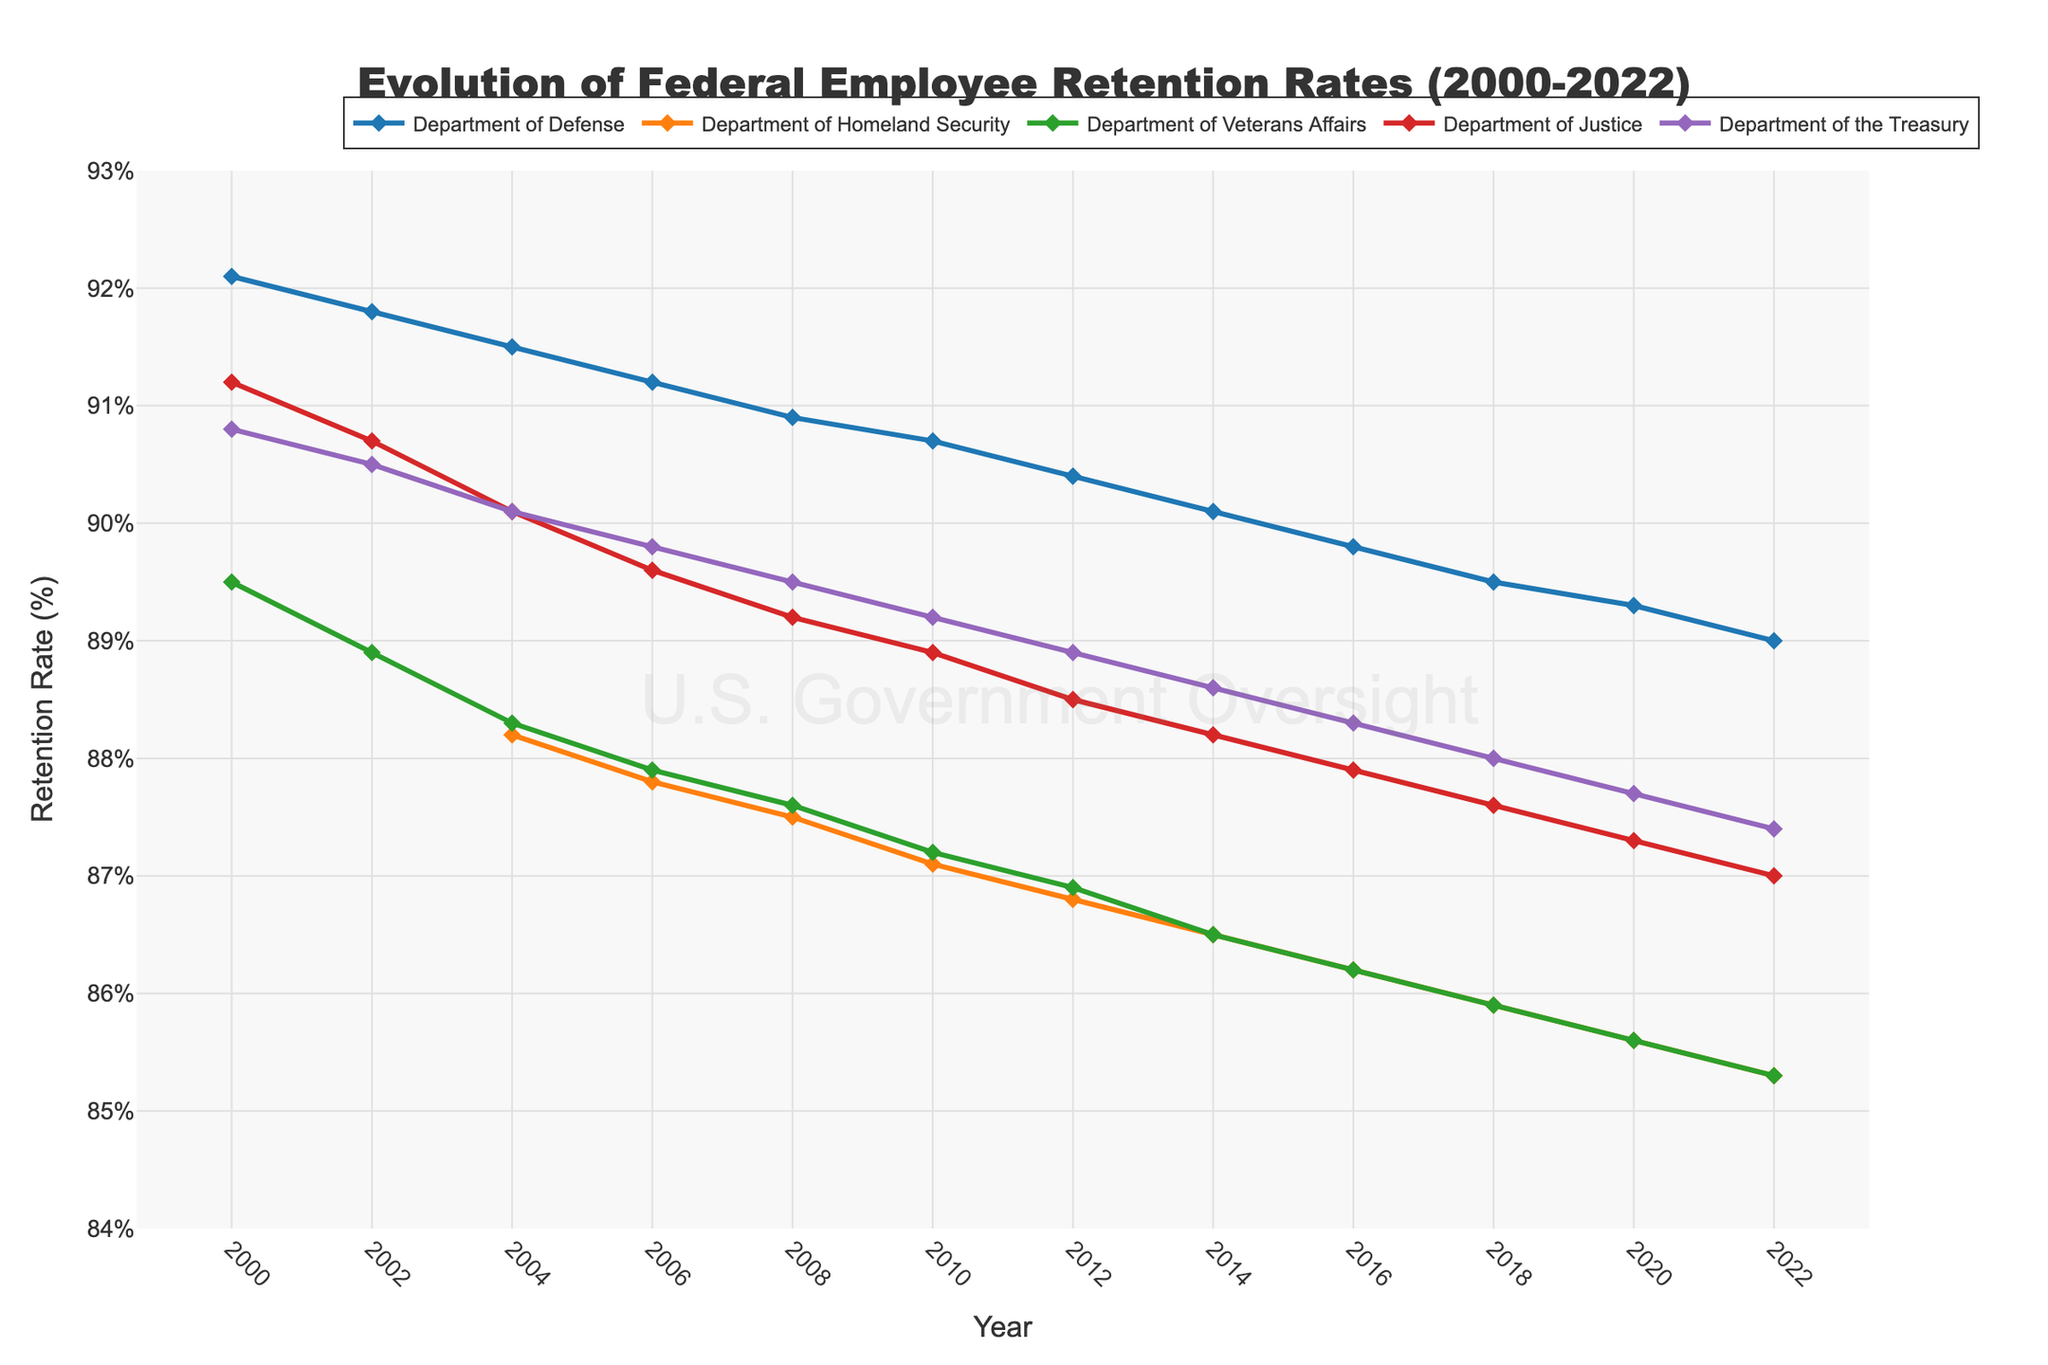Which agency had the highest retention rate in 2022? Look at the retention rates for each agency in 2022. The Department of Defense has the highest rate at 89.0%.
Answer: Department of Defense Comparing the Department of Homeland Security and the Department of Veterans Affairs, which had a higher retention rate in 2010? In 2010, the Department of Homeland Security had a retention rate of 87.1%, and the Department of Veterans Affairs had a retention rate of 87.2%. Thus, the Department of Veterans Affairs had a slightly higher retention rate.
Answer: Department of Veterans Affairs What is the average retention rate of the Department of the Treasury over the years 2000, 2002, and 2004? The retention rates for the Department of the Treasury in 2000, 2002, and 2004 are 90.8%, 90.5%, and 90.1%, respectively. The average is (90.8 + 90.5 + 90.1) / 3 = 90.47%.
Answer: 90.47% By how much did the retention rate of the Department of Justice change from 2000 to 2022? The retention rate of the Department of Justice in 2000 was 91.2%, and in 2022 it was 87.0%. The change is 91.2 - 87.0 = 4.2%.
Answer: 4.2% In what year did the Department of Homeland Security's retention rate first appear on the chart, and what was it? The Department of Homeland Security's retention rate first appears in 2004 with a rate of 88.2%.
Answer: 2004, 88.2% Which agency experienced the most consistent decline in retention rates from 2000 to 2022? To find the most consistent decline, compare the retention rates of each agency over the years. The Department of Homeland Security shows a steady decline from 88.2% in 2004 to 85.3% in 2022.
Answer: Department of Homeland Security What visual attribute is used to differentiate between the agencies on the line chart? The figure uses different colored lines and markers to differentiate between the agencies.
Answer: Different colored lines and markers Which two agencies had nearly identical retention rates in 2012, and what were those rates? In 2012, the Department of Justice had a retention rate of 88.5%, and the Department of the Treasury had a retention rate of 88.9%.
Answer: Department of Justice, Department of the Treasury, about 88.5% By what percentage did the retention rate of the Department of Veterans Affairs decrease from 2000 to 2022? The retention rate of the Department of Veterans Affairs was 89.5% in 2000 and dropped to 85.3% in 2022. The percentage decrease is ((89.5 - 85.3) / 89.5) * 100 ≈ 4.69%.
Answer: 4.69% Did any agency have a retention rate of exactly 90% in any year, and if so, which agency and year? No agency had a retention rate of exactly 90% in any given year visible in the chart.
Answer: None 